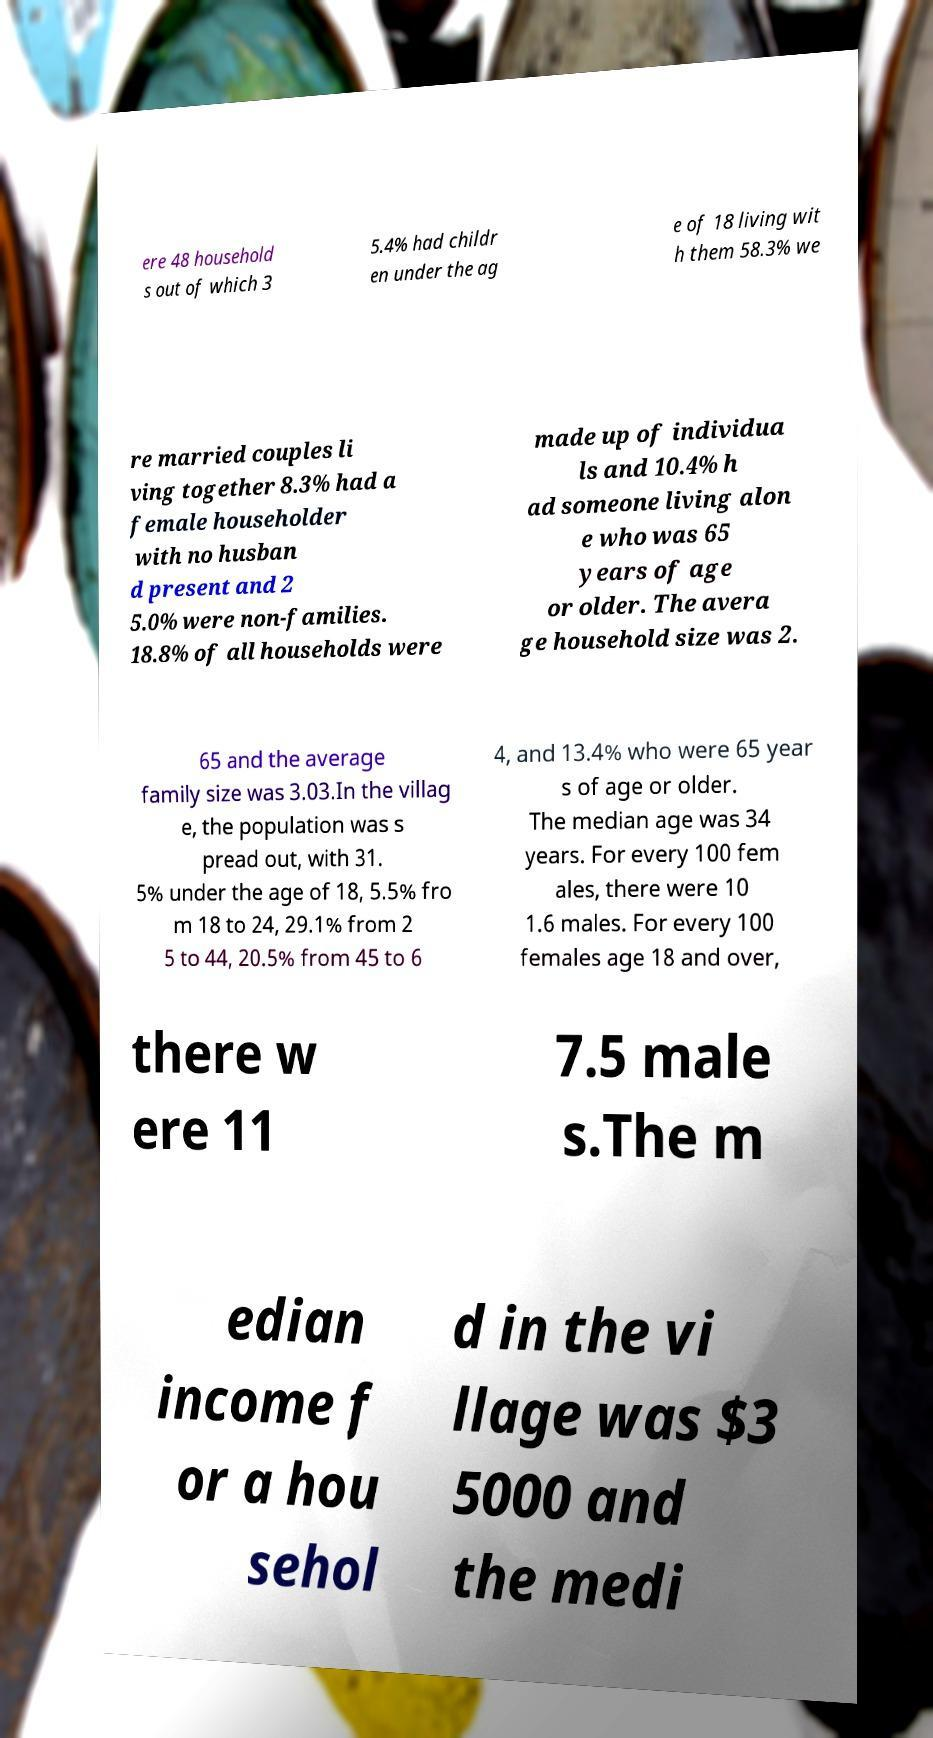Please identify and transcribe the text found in this image. ere 48 household s out of which 3 5.4% had childr en under the ag e of 18 living wit h them 58.3% we re married couples li ving together 8.3% had a female householder with no husban d present and 2 5.0% were non-families. 18.8% of all households were made up of individua ls and 10.4% h ad someone living alon e who was 65 years of age or older. The avera ge household size was 2. 65 and the average family size was 3.03.In the villag e, the population was s pread out, with 31. 5% under the age of 18, 5.5% fro m 18 to 24, 29.1% from 2 5 to 44, 20.5% from 45 to 6 4, and 13.4% who were 65 year s of age or older. The median age was 34 years. For every 100 fem ales, there were 10 1.6 males. For every 100 females age 18 and over, there w ere 11 7.5 male s.The m edian income f or a hou sehol d in the vi llage was $3 5000 and the medi 